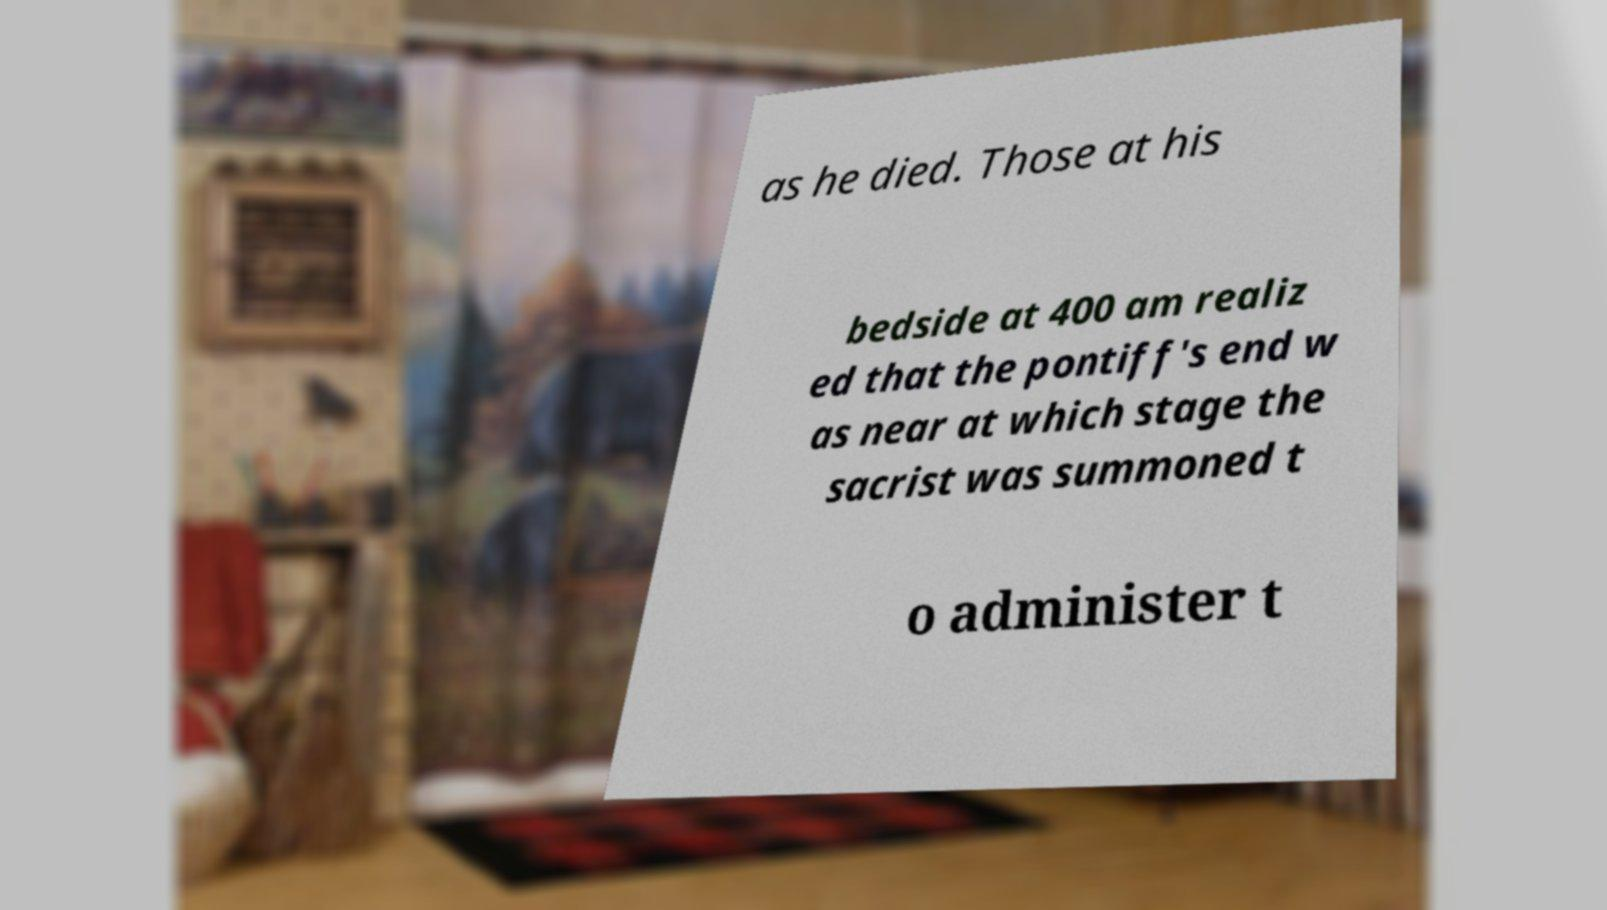Could you assist in decoding the text presented in this image and type it out clearly? as he died. Those at his bedside at 400 am realiz ed that the pontiff's end w as near at which stage the sacrist was summoned t o administer t 